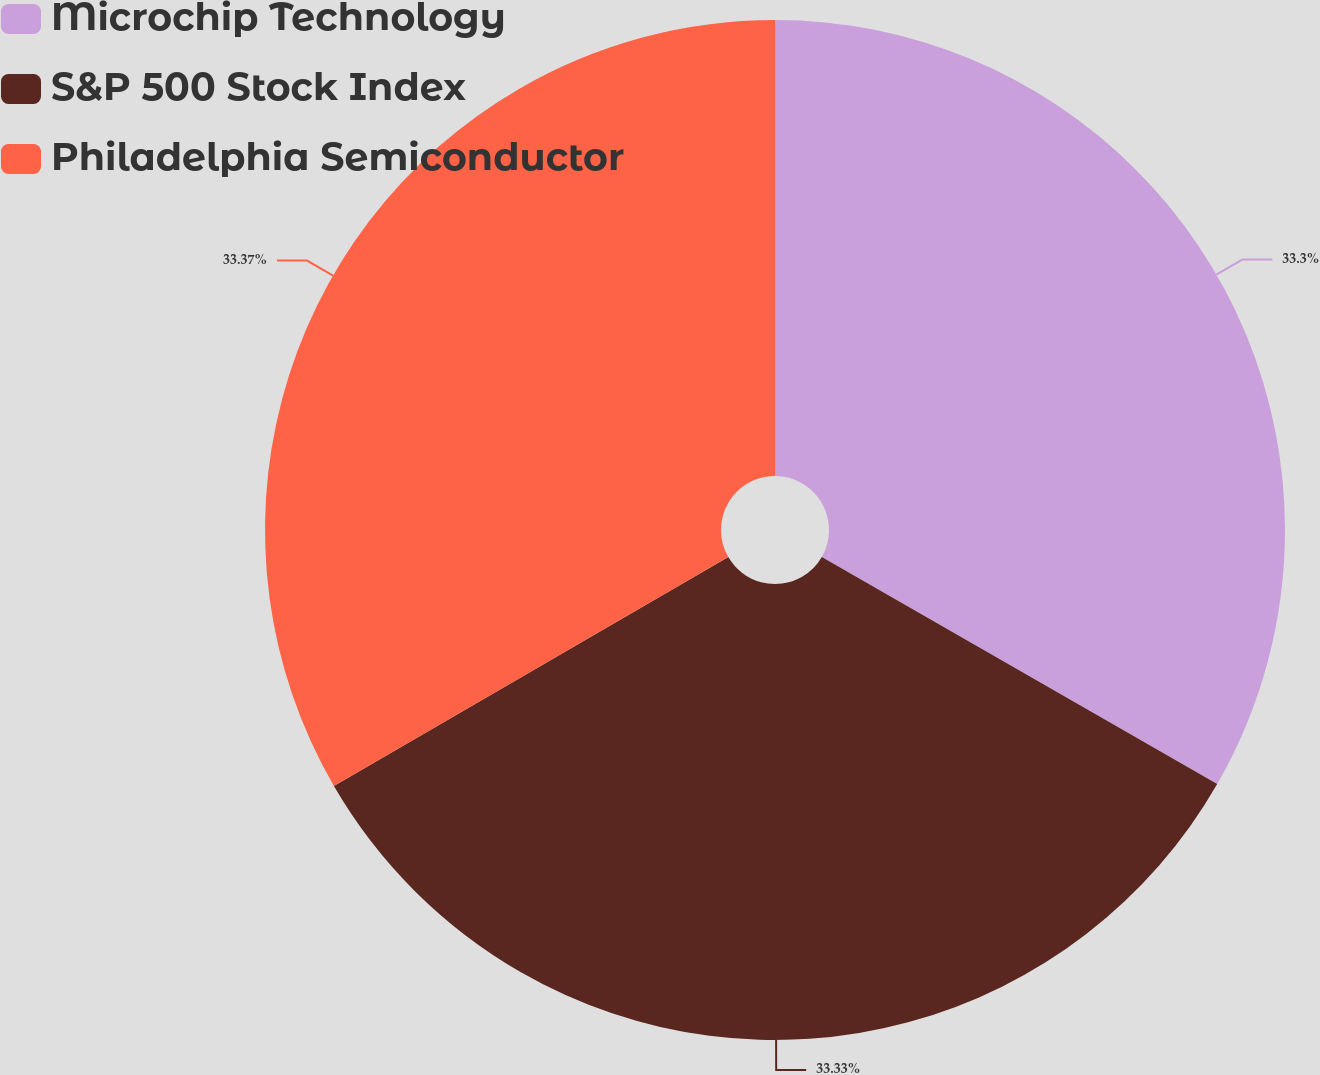Convert chart. <chart><loc_0><loc_0><loc_500><loc_500><pie_chart><fcel>Microchip Technology<fcel>S&P 500 Stock Index<fcel>Philadelphia Semiconductor<nl><fcel>33.3%<fcel>33.33%<fcel>33.37%<nl></chart> 